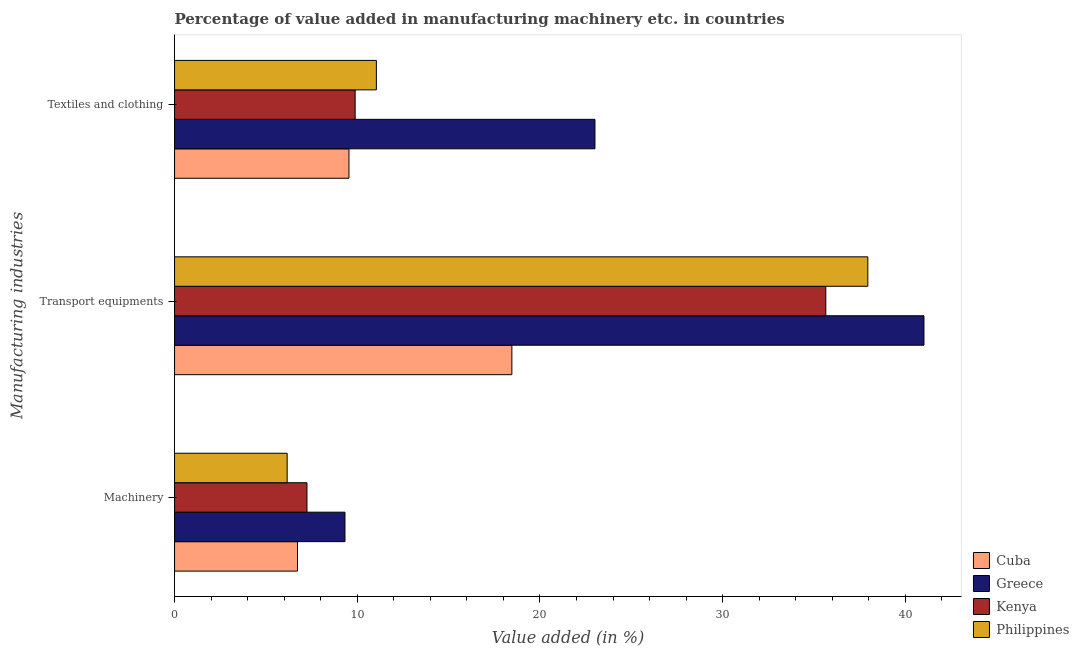Are the number of bars per tick equal to the number of legend labels?
Offer a very short reply. Yes. How many bars are there on the 3rd tick from the top?
Provide a short and direct response. 4. What is the label of the 2nd group of bars from the top?
Provide a short and direct response. Transport equipments. What is the value added in manufacturing textile and clothing in Cuba?
Your response must be concise. 9.54. Across all countries, what is the maximum value added in manufacturing machinery?
Provide a short and direct response. 9.33. Across all countries, what is the minimum value added in manufacturing machinery?
Offer a terse response. 6.16. In which country was the value added in manufacturing machinery maximum?
Ensure brevity in your answer.  Greece. In which country was the value added in manufacturing transport equipments minimum?
Provide a short and direct response. Cuba. What is the total value added in manufacturing machinery in the graph?
Offer a terse response. 29.47. What is the difference between the value added in manufacturing textile and clothing in Kenya and that in Philippines?
Your answer should be very brief. -1.16. What is the difference between the value added in manufacturing transport equipments in Philippines and the value added in manufacturing textile and clothing in Kenya?
Ensure brevity in your answer.  28.06. What is the average value added in manufacturing textile and clothing per country?
Keep it short and to the point. 13.37. What is the difference between the value added in manufacturing textile and clothing and value added in manufacturing transport equipments in Kenya?
Make the answer very short. -25.76. In how many countries, is the value added in manufacturing transport equipments greater than 18 %?
Your response must be concise. 4. What is the ratio of the value added in manufacturing transport equipments in Greece to that in Cuba?
Offer a terse response. 2.22. What is the difference between the highest and the second highest value added in manufacturing transport equipments?
Your answer should be very brief. 3.07. What is the difference between the highest and the lowest value added in manufacturing transport equipments?
Your response must be concise. 22.55. In how many countries, is the value added in manufacturing machinery greater than the average value added in manufacturing machinery taken over all countries?
Keep it short and to the point. 1. Is the sum of the value added in manufacturing transport equipments in Cuba and Kenya greater than the maximum value added in manufacturing textile and clothing across all countries?
Provide a short and direct response. Yes. What does the 2nd bar from the top in Transport equipments represents?
Make the answer very short. Kenya. What does the 4th bar from the bottom in Machinery represents?
Provide a succinct answer. Philippines. Is it the case that in every country, the sum of the value added in manufacturing machinery and value added in manufacturing transport equipments is greater than the value added in manufacturing textile and clothing?
Provide a succinct answer. Yes. How many countries are there in the graph?
Your response must be concise. 4. What is the difference between two consecutive major ticks on the X-axis?
Your answer should be compact. 10. What is the title of the graph?
Offer a very short reply. Percentage of value added in manufacturing machinery etc. in countries. Does "Monaco" appear as one of the legend labels in the graph?
Offer a terse response. No. What is the label or title of the X-axis?
Provide a short and direct response. Value added (in %). What is the label or title of the Y-axis?
Your answer should be compact. Manufacturing industries. What is the Value added (in %) in Cuba in Machinery?
Provide a short and direct response. 6.73. What is the Value added (in %) of Greece in Machinery?
Your answer should be compact. 9.33. What is the Value added (in %) of Kenya in Machinery?
Offer a very short reply. 7.25. What is the Value added (in %) of Philippines in Machinery?
Provide a short and direct response. 6.16. What is the Value added (in %) in Cuba in Transport equipments?
Offer a very short reply. 18.46. What is the Value added (in %) of Greece in Transport equipments?
Keep it short and to the point. 41.02. What is the Value added (in %) in Kenya in Transport equipments?
Give a very brief answer. 35.64. What is the Value added (in %) in Philippines in Transport equipments?
Your answer should be compact. 37.94. What is the Value added (in %) of Cuba in Textiles and clothing?
Your answer should be compact. 9.54. What is the Value added (in %) in Greece in Textiles and clothing?
Provide a succinct answer. 23.01. What is the Value added (in %) of Kenya in Textiles and clothing?
Keep it short and to the point. 9.88. What is the Value added (in %) in Philippines in Textiles and clothing?
Provide a short and direct response. 11.05. Across all Manufacturing industries, what is the maximum Value added (in %) in Cuba?
Ensure brevity in your answer.  18.46. Across all Manufacturing industries, what is the maximum Value added (in %) of Greece?
Make the answer very short. 41.02. Across all Manufacturing industries, what is the maximum Value added (in %) of Kenya?
Provide a succinct answer. 35.64. Across all Manufacturing industries, what is the maximum Value added (in %) of Philippines?
Your answer should be compact. 37.94. Across all Manufacturing industries, what is the minimum Value added (in %) of Cuba?
Offer a terse response. 6.73. Across all Manufacturing industries, what is the minimum Value added (in %) in Greece?
Ensure brevity in your answer.  9.33. Across all Manufacturing industries, what is the minimum Value added (in %) in Kenya?
Give a very brief answer. 7.25. Across all Manufacturing industries, what is the minimum Value added (in %) in Philippines?
Ensure brevity in your answer.  6.16. What is the total Value added (in %) of Cuba in the graph?
Keep it short and to the point. 34.74. What is the total Value added (in %) in Greece in the graph?
Your answer should be very brief. 73.35. What is the total Value added (in %) of Kenya in the graph?
Provide a succinct answer. 52.78. What is the total Value added (in %) of Philippines in the graph?
Provide a succinct answer. 55.15. What is the difference between the Value added (in %) in Cuba in Machinery and that in Transport equipments?
Make the answer very short. -11.73. What is the difference between the Value added (in %) in Greece in Machinery and that in Transport equipments?
Your answer should be very brief. -31.69. What is the difference between the Value added (in %) of Kenya in Machinery and that in Transport equipments?
Offer a very short reply. -28.4. What is the difference between the Value added (in %) of Philippines in Machinery and that in Transport equipments?
Ensure brevity in your answer.  -31.78. What is the difference between the Value added (in %) in Cuba in Machinery and that in Textiles and clothing?
Provide a short and direct response. -2.82. What is the difference between the Value added (in %) in Greece in Machinery and that in Textiles and clothing?
Ensure brevity in your answer.  -13.68. What is the difference between the Value added (in %) of Kenya in Machinery and that in Textiles and clothing?
Offer a terse response. -2.64. What is the difference between the Value added (in %) of Philippines in Machinery and that in Textiles and clothing?
Your response must be concise. -4.88. What is the difference between the Value added (in %) in Cuba in Transport equipments and that in Textiles and clothing?
Keep it short and to the point. 8.92. What is the difference between the Value added (in %) in Greece in Transport equipments and that in Textiles and clothing?
Offer a terse response. 18.01. What is the difference between the Value added (in %) in Kenya in Transport equipments and that in Textiles and clothing?
Provide a succinct answer. 25.76. What is the difference between the Value added (in %) in Philippines in Transport equipments and that in Textiles and clothing?
Offer a very short reply. 26.9. What is the difference between the Value added (in %) in Cuba in Machinery and the Value added (in %) in Greece in Transport equipments?
Provide a short and direct response. -34.29. What is the difference between the Value added (in %) of Cuba in Machinery and the Value added (in %) of Kenya in Transport equipments?
Offer a very short reply. -28.91. What is the difference between the Value added (in %) in Cuba in Machinery and the Value added (in %) in Philippines in Transport equipments?
Give a very brief answer. -31.21. What is the difference between the Value added (in %) of Greece in Machinery and the Value added (in %) of Kenya in Transport equipments?
Ensure brevity in your answer.  -26.32. What is the difference between the Value added (in %) in Greece in Machinery and the Value added (in %) in Philippines in Transport equipments?
Provide a short and direct response. -28.62. What is the difference between the Value added (in %) of Kenya in Machinery and the Value added (in %) of Philippines in Transport equipments?
Your answer should be very brief. -30.7. What is the difference between the Value added (in %) of Cuba in Machinery and the Value added (in %) of Greece in Textiles and clothing?
Your answer should be compact. -16.28. What is the difference between the Value added (in %) of Cuba in Machinery and the Value added (in %) of Kenya in Textiles and clothing?
Make the answer very short. -3.16. What is the difference between the Value added (in %) of Cuba in Machinery and the Value added (in %) of Philippines in Textiles and clothing?
Ensure brevity in your answer.  -4.32. What is the difference between the Value added (in %) of Greece in Machinery and the Value added (in %) of Kenya in Textiles and clothing?
Your answer should be very brief. -0.56. What is the difference between the Value added (in %) of Greece in Machinery and the Value added (in %) of Philippines in Textiles and clothing?
Keep it short and to the point. -1.72. What is the difference between the Value added (in %) in Kenya in Machinery and the Value added (in %) in Philippines in Textiles and clothing?
Provide a succinct answer. -3.8. What is the difference between the Value added (in %) in Cuba in Transport equipments and the Value added (in %) in Greece in Textiles and clothing?
Provide a succinct answer. -4.55. What is the difference between the Value added (in %) in Cuba in Transport equipments and the Value added (in %) in Kenya in Textiles and clothing?
Ensure brevity in your answer.  8.58. What is the difference between the Value added (in %) of Cuba in Transport equipments and the Value added (in %) of Philippines in Textiles and clothing?
Your response must be concise. 7.42. What is the difference between the Value added (in %) in Greece in Transport equipments and the Value added (in %) in Kenya in Textiles and clothing?
Your answer should be compact. 31.13. What is the difference between the Value added (in %) in Greece in Transport equipments and the Value added (in %) in Philippines in Textiles and clothing?
Provide a succinct answer. 29.97. What is the difference between the Value added (in %) of Kenya in Transport equipments and the Value added (in %) of Philippines in Textiles and clothing?
Make the answer very short. 24.6. What is the average Value added (in %) in Cuba per Manufacturing industries?
Your response must be concise. 11.58. What is the average Value added (in %) in Greece per Manufacturing industries?
Ensure brevity in your answer.  24.45. What is the average Value added (in %) in Kenya per Manufacturing industries?
Make the answer very short. 17.59. What is the average Value added (in %) of Philippines per Manufacturing industries?
Offer a terse response. 18.38. What is the difference between the Value added (in %) of Cuba and Value added (in %) of Greece in Machinery?
Make the answer very short. -2.6. What is the difference between the Value added (in %) in Cuba and Value added (in %) in Kenya in Machinery?
Ensure brevity in your answer.  -0.52. What is the difference between the Value added (in %) in Cuba and Value added (in %) in Philippines in Machinery?
Offer a very short reply. 0.57. What is the difference between the Value added (in %) of Greece and Value added (in %) of Kenya in Machinery?
Give a very brief answer. 2.08. What is the difference between the Value added (in %) in Greece and Value added (in %) in Philippines in Machinery?
Your answer should be very brief. 3.16. What is the difference between the Value added (in %) of Kenya and Value added (in %) of Philippines in Machinery?
Your response must be concise. 1.08. What is the difference between the Value added (in %) in Cuba and Value added (in %) in Greece in Transport equipments?
Ensure brevity in your answer.  -22.55. What is the difference between the Value added (in %) in Cuba and Value added (in %) in Kenya in Transport equipments?
Keep it short and to the point. -17.18. What is the difference between the Value added (in %) in Cuba and Value added (in %) in Philippines in Transport equipments?
Keep it short and to the point. -19.48. What is the difference between the Value added (in %) of Greece and Value added (in %) of Kenya in Transport equipments?
Give a very brief answer. 5.37. What is the difference between the Value added (in %) in Greece and Value added (in %) in Philippines in Transport equipments?
Provide a succinct answer. 3.07. What is the difference between the Value added (in %) in Kenya and Value added (in %) in Philippines in Transport equipments?
Ensure brevity in your answer.  -2.3. What is the difference between the Value added (in %) in Cuba and Value added (in %) in Greece in Textiles and clothing?
Your response must be concise. -13.46. What is the difference between the Value added (in %) in Cuba and Value added (in %) in Kenya in Textiles and clothing?
Your answer should be compact. -0.34. What is the difference between the Value added (in %) of Cuba and Value added (in %) of Philippines in Textiles and clothing?
Your answer should be compact. -1.5. What is the difference between the Value added (in %) in Greece and Value added (in %) in Kenya in Textiles and clothing?
Ensure brevity in your answer.  13.12. What is the difference between the Value added (in %) of Greece and Value added (in %) of Philippines in Textiles and clothing?
Keep it short and to the point. 11.96. What is the difference between the Value added (in %) of Kenya and Value added (in %) of Philippines in Textiles and clothing?
Your response must be concise. -1.16. What is the ratio of the Value added (in %) of Cuba in Machinery to that in Transport equipments?
Offer a very short reply. 0.36. What is the ratio of the Value added (in %) of Greece in Machinery to that in Transport equipments?
Keep it short and to the point. 0.23. What is the ratio of the Value added (in %) in Kenya in Machinery to that in Transport equipments?
Keep it short and to the point. 0.2. What is the ratio of the Value added (in %) in Philippines in Machinery to that in Transport equipments?
Offer a terse response. 0.16. What is the ratio of the Value added (in %) in Cuba in Machinery to that in Textiles and clothing?
Your answer should be compact. 0.7. What is the ratio of the Value added (in %) in Greece in Machinery to that in Textiles and clothing?
Keep it short and to the point. 0.41. What is the ratio of the Value added (in %) of Kenya in Machinery to that in Textiles and clothing?
Offer a very short reply. 0.73. What is the ratio of the Value added (in %) of Philippines in Machinery to that in Textiles and clothing?
Provide a short and direct response. 0.56. What is the ratio of the Value added (in %) in Cuba in Transport equipments to that in Textiles and clothing?
Offer a very short reply. 1.93. What is the ratio of the Value added (in %) of Greece in Transport equipments to that in Textiles and clothing?
Ensure brevity in your answer.  1.78. What is the ratio of the Value added (in %) of Kenya in Transport equipments to that in Textiles and clothing?
Your answer should be compact. 3.61. What is the ratio of the Value added (in %) in Philippines in Transport equipments to that in Textiles and clothing?
Your answer should be very brief. 3.44. What is the difference between the highest and the second highest Value added (in %) in Cuba?
Your response must be concise. 8.92. What is the difference between the highest and the second highest Value added (in %) in Greece?
Make the answer very short. 18.01. What is the difference between the highest and the second highest Value added (in %) of Kenya?
Provide a short and direct response. 25.76. What is the difference between the highest and the second highest Value added (in %) of Philippines?
Provide a succinct answer. 26.9. What is the difference between the highest and the lowest Value added (in %) in Cuba?
Your answer should be compact. 11.73. What is the difference between the highest and the lowest Value added (in %) in Greece?
Keep it short and to the point. 31.69. What is the difference between the highest and the lowest Value added (in %) in Kenya?
Your answer should be compact. 28.4. What is the difference between the highest and the lowest Value added (in %) of Philippines?
Provide a short and direct response. 31.78. 